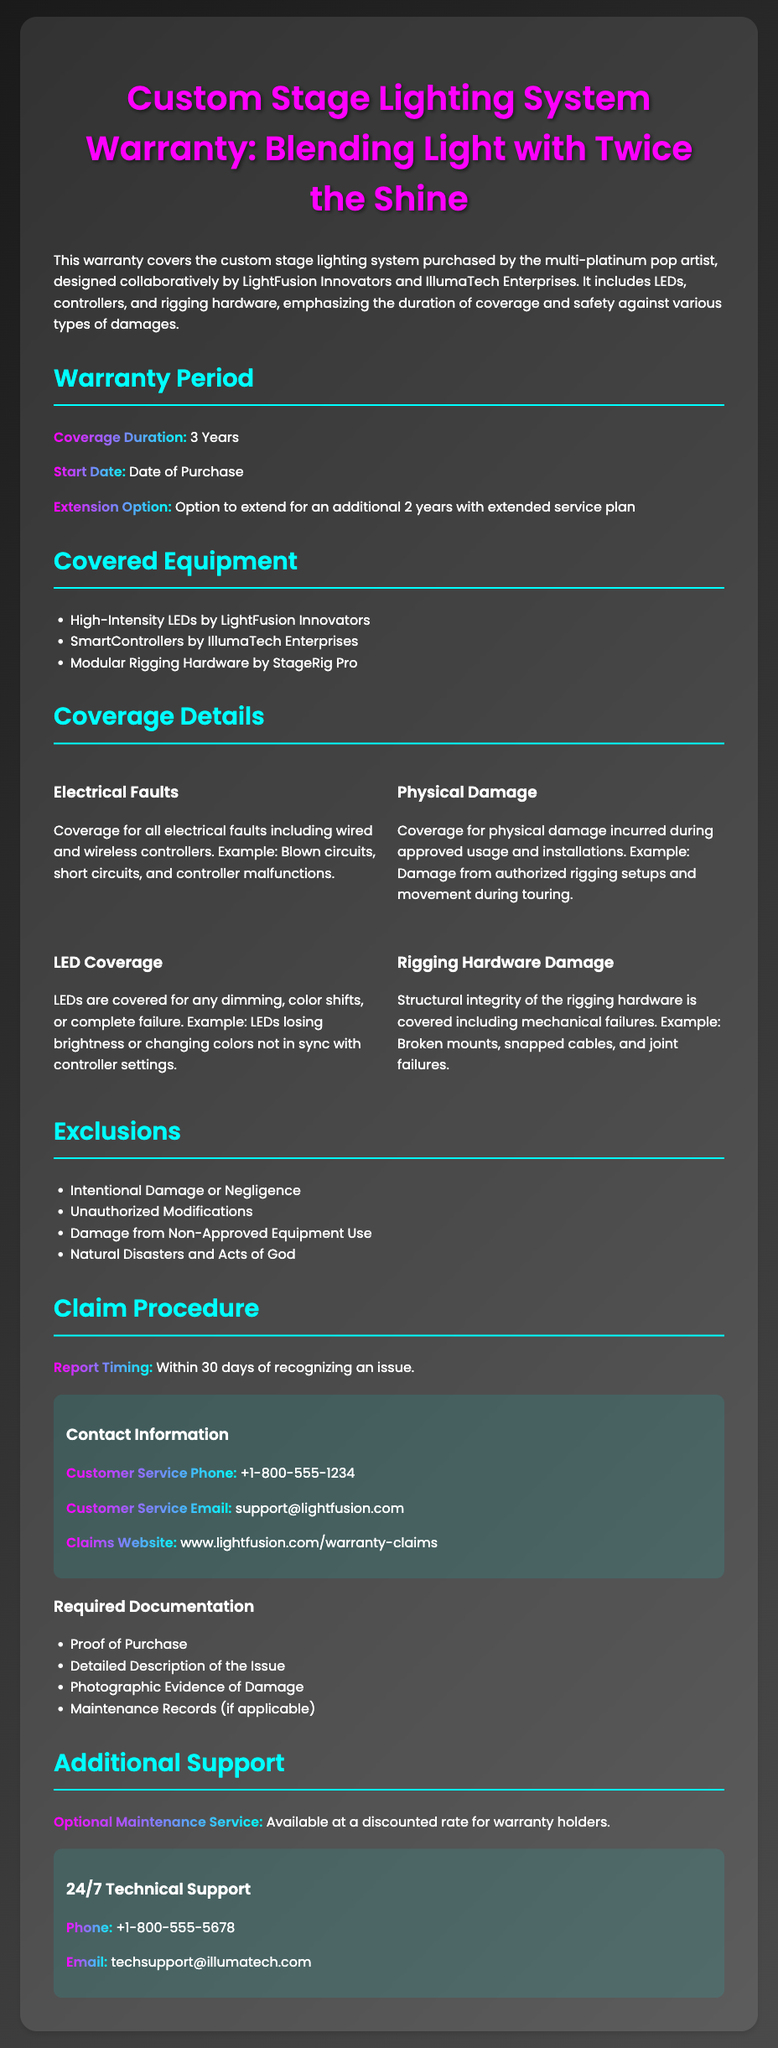What is the warranty coverage duration? The warranty coverage duration is stated as 3 Years in the document.
Answer: 3 Years When does the warranty start? The document specifies that the warranty start date is the Date of Purchase.
Answer: Date of Purchase Which types of faults are covered? The coverage details mention that electrical faults, physical damage, LED issues, and rigging hardware damage are included.
Answer: Electrical faults How long can the warranty be extended? The document indicates that there is an option to extend the warranty for an additional 2 years.
Answer: 2 years What should be done within 30 days of recognizing an issue? The claim procedure mentions that issues need to be reported within 30 days.
Answer: Report the issue What type of damage is excluded from the warranty? The document lists intentional damage or negligence as one of the exclusions.
Answer: Intentional Damage What is required to make a claim? The required documentation for a claim includes proof of purchase among other items.
Answer: Proof of Purchase Which company manufactures the LEDs? The document states that the High-Intensity LEDs are by LightFusion Innovators.
Answer: LightFusion Innovators What type of support is available for warranty holders? The document mentions that an optional maintenance service is available at a discounted rate for warranty holders.
Answer: Optional Maintenance Service 